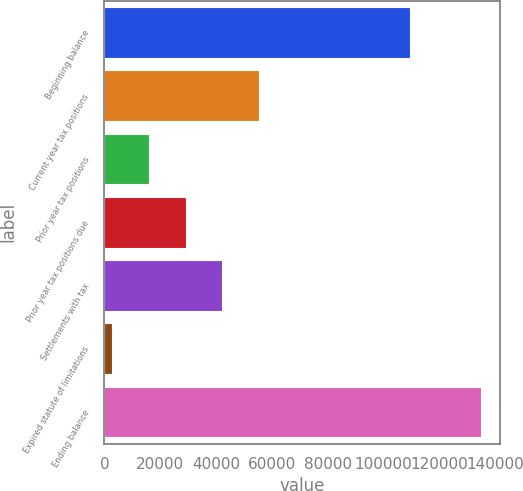<chart> <loc_0><loc_0><loc_500><loc_500><bar_chart><fcel>Beginning balance<fcel>Current year tax positions<fcel>Prior year tax positions<fcel>Prior year tax positions due<fcel>Settlements with tax<fcel>Expired statute of limitations<fcel>Ending balance<nl><fcel>109476<fcel>55494<fcel>15828<fcel>29050<fcel>42272<fcel>2606<fcel>134826<nl></chart> 